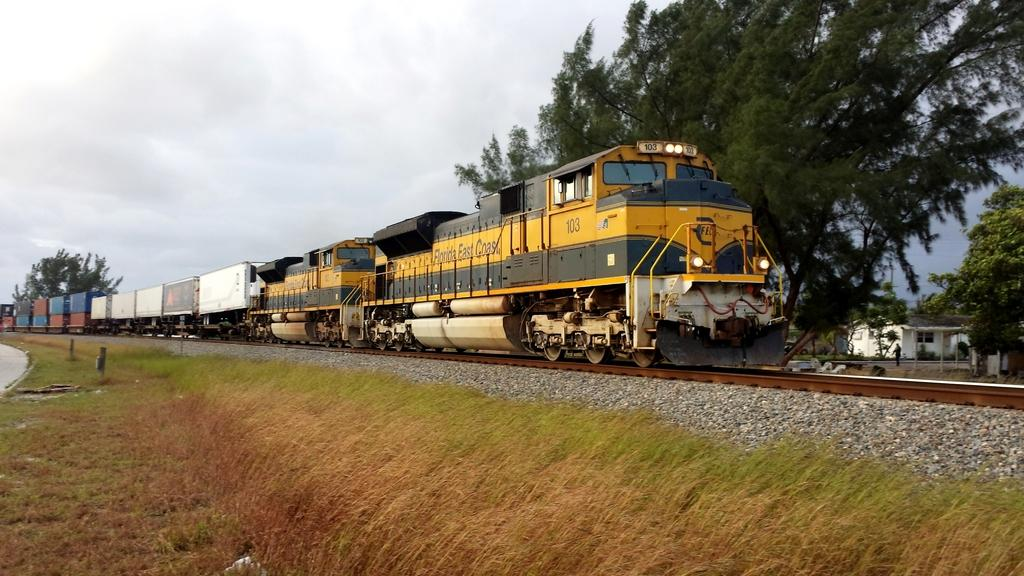What type of objects can be seen on the ground in the image? There are stones in the image. What mode of transportation is present in the image? There is a train on the tracks in the image. What can be seen in the background of the image? There are trees, a house, and a person visible in the background of the image. What is visible in the sky in the image? There are clouds visible in the image. How many plants are being herded by the geese in the image? There are no plants or geese present in the image. What type of animal is grazing in the background of the image? There are no animals grazing in the background of the image; only a person, trees, and a house are visible. 